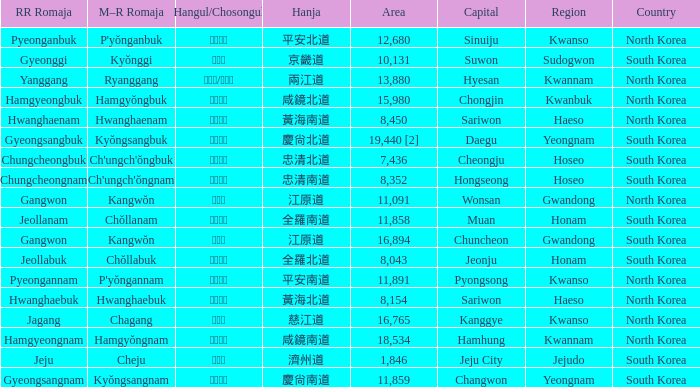Which country has a city with a Hanja of 平安北道? North Korea. 